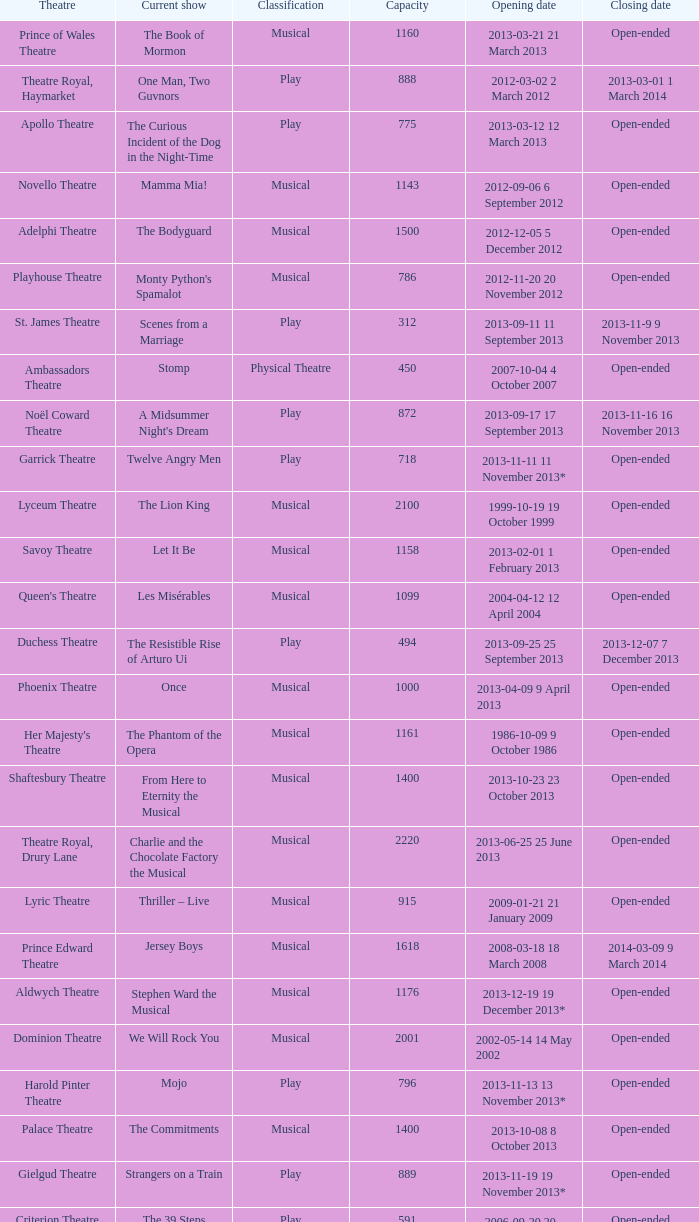What is the opening date of the musical at the adelphi theatre? 2012-12-05 5 December 2012. 